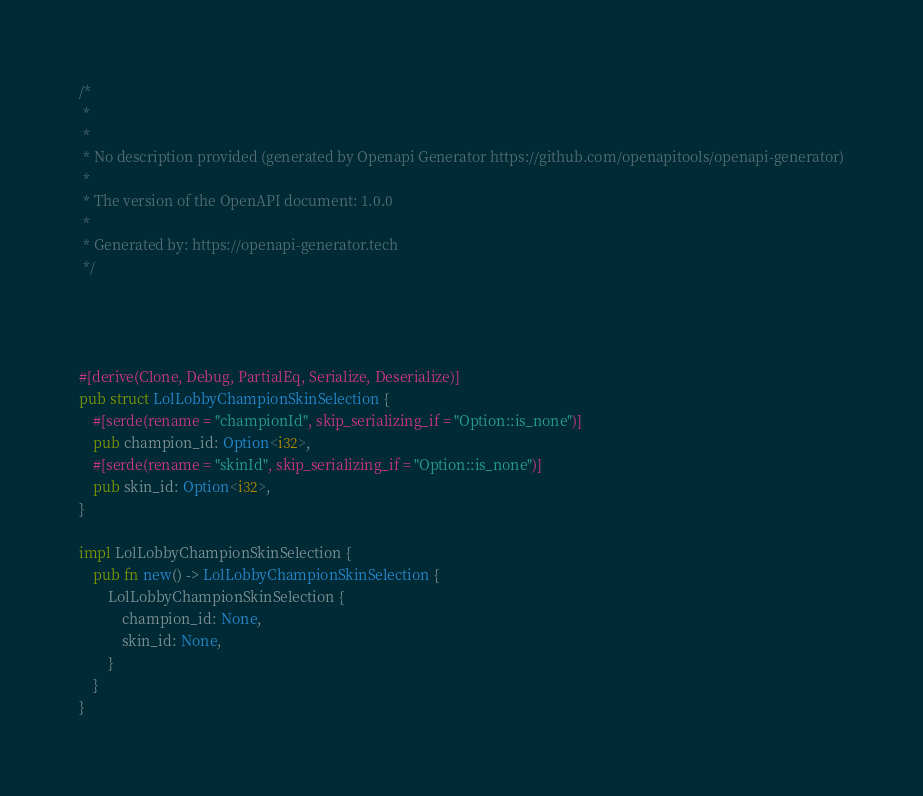<code> <loc_0><loc_0><loc_500><loc_500><_Rust_>/*
 * 
 *
 * No description provided (generated by Openapi Generator https://github.com/openapitools/openapi-generator)
 *
 * The version of the OpenAPI document: 1.0.0
 * 
 * Generated by: https://openapi-generator.tech
 */




#[derive(Clone, Debug, PartialEq, Serialize, Deserialize)]
pub struct LolLobbyChampionSkinSelection {
    #[serde(rename = "championId", skip_serializing_if = "Option::is_none")]
    pub champion_id: Option<i32>,
    #[serde(rename = "skinId", skip_serializing_if = "Option::is_none")]
    pub skin_id: Option<i32>,
}

impl LolLobbyChampionSkinSelection {
    pub fn new() -> LolLobbyChampionSkinSelection {
        LolLobbyChampionSkinSelection {
            champion_id: None,
            skin_id: None,
        }
    }
}


</code> 